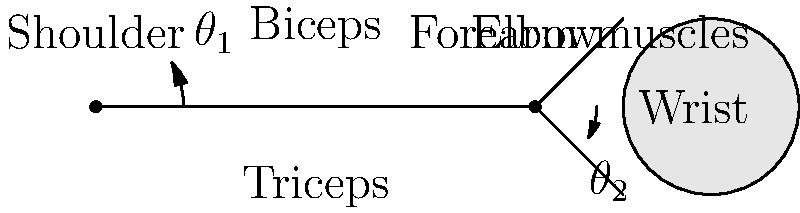When kneading dough, which combination of joint angles ($\theta_1$ for shoulder and $\theta_2$ for elbow) and muscle engagement would typically result in the most effective downward force application? To answer this question, we need to consider the biomechanics of kneading dough:

1. Shoulder angle ($\theta_1$):
   - A moderate shoulder flexion angle (around 30-45 degrees) allows for optimal force transfer from the upper body.
   - This angle engages the anterior deltoid and pectoralis major muscles.

2. Elbow angle ($\theta_2$):
   - A slightly flexed elbow (around 15-30 degrees) provides stability and allows for better force control.
   - This angle engages both the biceps and triceps muscles for push-pull movements.

3. Muscle engagement:
   - Biceps: Engaged during the pulling phase of kneading.
   - Triceps: Activated during the pushing phase.
   - Forearm muscles: Continuously engaged for gripping and manipulating the dough.

4. Downward force application:
   - The combination of these joint angles allows for a more vertical alignment of the arm.
   - This alignment helps transfer body weight into the dough more effectively.

5. Wrist position:
   - A neutral wrist position (not shown in the diagram) is important to prevent strain.

The most effective combination would be:
- $\theta_1 \approx 30-45°$ (shoulder flexion)
- $\theta_2 \approx 15-30°$ (slight elbow flexion)
- Alternating engagement of biceps and triceps
- Constant engagement of forearm muscles

This combination allows for a good balance between force application, control, and endurance during the kneading process.
Answer: $\theta_1 \approx 30-45°$, $\theta_2 \approx 15-30°$, alternating biceps/triceps engagement, constant forearm activation 